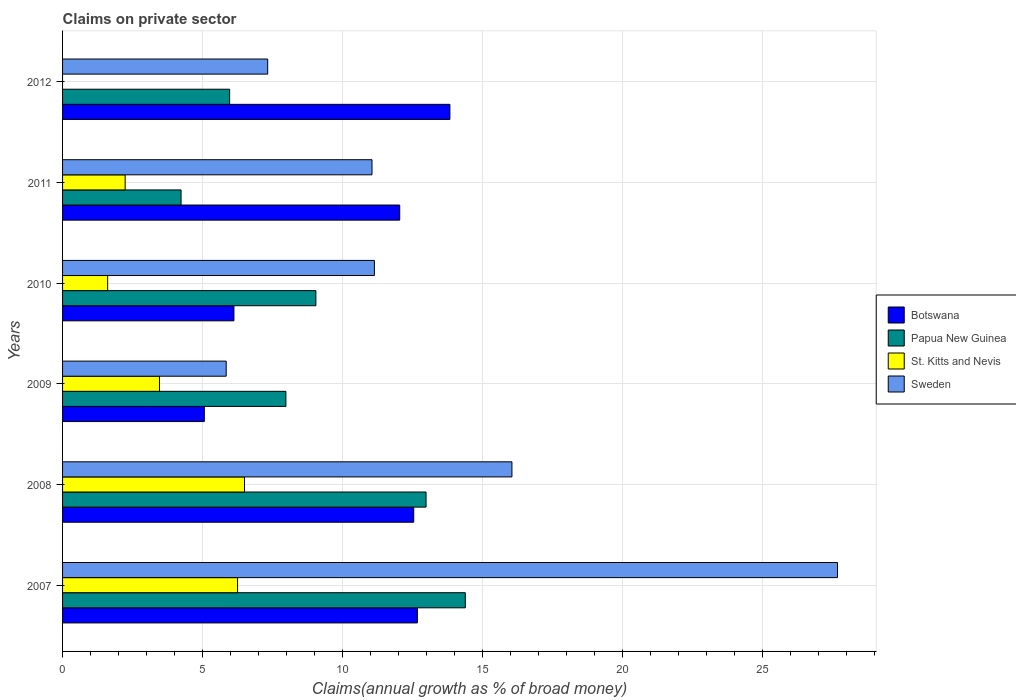How many different coloured bars are there?
Offer a very short reply. 4. Are the number of bars per tick equal to the number of legend labels?
Provide a short and direct response. No. How many bars are there on the 3rd tick from the top?
Provide a succinct answer. 4. How many bars are there on the 3rd tick from the bottom?
Make the answer very short. 4. In how many cases, is the number of bars for a given year not equal to the number of legend labels?
Your response must be concise. 1. What is the percentage of broad money claimed on private sector in Sweden in 2012?
Offer a very short reply. 7.32. Across all years, what is the maximum percentage of broad money claimed on private sector in Botswana?
Keep it short and to the point. 13.83. In which year was the percentage of broad money claimed on private sector in Botswana maximum?
Your response must be concise. 2012. What is the total percentage of broad money claimed on private sector in St. Kitts and Nevis in the graph?
Give a very brief answer. 20.05. What is the difference between the percentage of broad money claimed on private sector in Botswana in 2007 and that in 2008?
Provide a short and direct response. 0.13. What is the difference between the percentage of broad money claimed on private sector in Botswana in 2007 and the percentage of broad money claimed on private sector in St. Kitts and Nevis in 2012?
Provide a succinct answer. 12.67. What is the average percentage of broad money claimed on private sector in Botswana per year?
Offer a very short reply. 10.37. In the year 2010, what is the difference between the percentage of broad money claimed on private sector in Papua New Guinea and percentage of broad money claimed on private sector in St. Kitts and Nevis?
Offer a terse response. 7.43. In how many years, is the percentage of broad money claimed on private sector in St. Kitts and Nevis greater than 10 %?
Provide a succinct answer. 0. What is the ratio of the percentage of broad money claimed on private sector in St. Kitts and Nevis in 2007 to that in 2011?
Offer a very short reply. 2.8. Is the percentage of broad money claimed on private sector in Botswana in 2007 less than that in 2011?
Make the answer very short. No. What is the difference between the highest and the second highest percentage of broad money claimed on private sector in St. Kitts and Nevis?
Offer a very short reply. 0.25. What is the difference between the highest and the lowest percentage of broad money claimed on private sector in Papua New Guinea?
Make the answer very short. 10.15. In how many years, is the percentage of broad money claimed on private sector in Papua New Guinea greater than the average percentage of broad money claimed on private sector in Papua New Guinea taken over all years?
Ensure brevity in your answer.  2. Is the sum of the percentage of broad money claimed on private sector in Sweden in 2009 and 2010 greater than the maximum percentage of broad money claimed on private sector in St. Kitts and Nevis across all years?
Give a very brief answer. Yes. Is it the case that in every year, the sum of the percentage of broad money claimed on private sector in Papua New Guinea and percentage of broad money claimed on private sector in St. Kitts and Nevis is greater than the sum of percentage of broad money claimed on private sector in Sweden and percentage of broad money claimed on private sector in Botswana?
Provide a succinct answer. Yes. Are all the bars in the graph horizontal?
Ensure brevity in your answer.  Yes. Are the values on the major ticks of X-axis written in scientific E-notation?
Your answer should be very brief. No. Does the graph contain any zero values?
Your answer should be very brief. Yes. Does the graph contain grids?
Offer a terse response. Yes. How many legend labels are there?
Your answer should be very brief. 4. How are the legend labels stacked?
Your answer should be compact. Vertical. What is the title of the graph?
Your response must be concise. Claims on private sector. Does "Philippines" appear as one of the legend labels in the graph?
Keep it short and to the point. No. What is the label or title of the X-axis?
Provide a succinct answer. Claims(annual growth as % of broad money). What is the label or title of the Y-axis?
Make the answer very short. Years. What is the Claims(annual growth as % of broad money) in Botswana in 2007?
Offer a terse response. 12.67. What is the Claims(annual growth as % of broad money) of Papua New Guinea in 2007?
Keep it short and to the point. 14.38. What is the Claims(annual growth as % of broad money) in St. Kitts and Nevis in 2007?
Make the answer very short. 6.25. What is the Claims(annual growth as % of broad money) of Sweden in 2007?
Offer a terse response. 27.66. What is the Claims(annual growth as % of broad money) in Botswana in 2008?
Your answer should be very brief. 12.54. What is the Claims(annual growth as % of broad money) in Papua New Guinea in 2008?
Keep it short and to the point. 12.98. What is the Claims(annual growth as % of broad money) of St. Kitts and Nevis in 2008?
Provide a succinct answer. 6.5. What is the Claims(annual growth as % of broad money) in Sweden in 2008?
Your response must be concise. 16.04. What is the Claims(annual growth as % of broad money) of Botswana in 2009?
Your response must be concise. 5.06. What is the Claims(annual growth as % of broad money) of Papua New Guinea in 2009?
Ensure brevity in your answer.  7.97. What is the Claims(annual growth as % of broad money) in St. Kitts and Nevis in 2009?
Make the answer very short. 3.46. What is the Claims(annual growth as % of broad money) in Sweden in 2009?
Offer a terse response. 5.84. What is the Claims(annual growth as % of broad money) of Botswana in 2010?
Your response must be concise. 6.12. What is the Claims(annual growth as % of broad money) in Papua New Guinea in 2010?
Your answer should be very brief. 9.04. What is the Claims(annual growth as % of broad money) of St. Kitts and Nevis in 2010?
Keep it short and to the point. 1.61. What is the Claims(annual growth as % of broad money) of Sweden in 2010?
Provide a short and direct response. 11.13. What is the Claims(annual growth as % of broad money) in Botswana in 2011?
Your answer should be very brief. 12.04. What is the Claims(annual growth as % of broad money) in Papua New Guinea in 2011?
Your answer should be very brief. 4.23. What is the Claims(annual growth as % of broad money) of St. Kitts and Nevis in 2011?
Ensure brevity in your answer.  2.23. What is the Claims(annual growth as % of broad money) in Sweden in 2011?
Ensure brevity in your answer.  11.05. What is the Claims(annual growth as % of broad money) of Botswana in 2012?
Offer a very short reply. 13.83. What is the Claims(annual growth as % of broad money) in Papua New Guinea in 2012?
Give a very brief answer. 5.96. What is the Claims(annual growth as % of broad money) of Sweden in 2012?
Your answer should be compact. 7.32. Across all years, what is the maximum Claims(annual growth as % of broad money) in Botswana?
Make the answer very short. 13.83. Across all years, what is the maximum Claims(annual growth as % of broad money) of Papua New Guinea?
Keep it short and to the point. 14.38. Across all years, what is the maximum Claims(annual growth as % of broad money) in St. Kitts and Nevis?
Offer a very short reply. 6.5. Across all years, what is the maximum Claims(annual growth as % of broad money) in Sweden?
Provide a succinct answer. 27.66. Across all years, what is the minimum Claims(annual growth as % of broad money) in Botswana?
Your response must be concise. 5.06. Across all years, what is the minimum Claims(annual growth as % of broad money) in Papua New Guinea?
Your response must be concise. 4.23. Across all years, what is the minimum Claims(annual growth as % of broad money) in St. Kitts and Nevis?
Your answer should be very brief. 0. Across all years, what is the minimum Claims(annual growth as % of broad money) in Sweden?
Keep it short and to the point. 5.84. What is the total Claims(annual growth as % of broad money) in Botswana in the graph?
Make the answer very short. 62.25. What is the total Claims(annual growth as % of broad money) of Papua New Guinea in the graph?
Make the answer very short. 54.56. What is the total Claims(annual growth as % of broad money) of St. Kitts and Nevis in the graph?
Keep it short and to the point. 20.05. What is the total Claims(annual growth as % of broad money) of Sweden in the graph?
Give a very brief answer. 79.05. What is the difference between the Claims(annual growth as % of broad money) in Botswana in 2007 and that in 2008?
Your response must be concise. 0.13. What is the difference between the Claims(annual growth as % of broad money) in Papua New Guinea in 2007 and that in 2008?
Your answer should be compact. 1.4. What is the difference between the Claims(annual growth as % of broad money) in St. Kitts and Nevis in 2007 and that in 2008?
Offer a terse response. -0.25. What is the difference between the Claims(annual growth as % of broad money) of Sweden in 2007 and that in 2008?
Your answer should be compact. 11.62. What is the difference between the Claims(annual growth as % of broad money) in Botswana in 2007 and that in 2009?
Keep it short and to the point. 7.61. What is the difference between the Claims(annual growth as % of broad money) of Papua New Guinea in 2007 and that in 2009?
Your answer should be compact. 6.41. What is the difference between the Claims(annual growth as % of broad money) in St. Kitts and Nevis in 2007 and that in 2009?
Keep it short and to the point. 2.79. What is the difference between the Claims(annual growth as % of broad money) in Sweden in 2007 and that in 2009?
Your answer should be very brief. 21.82. What is the difference between the Claims(annual growth as % of broad money) of Botswana in 2007 and that in 2010?
Give a very brief answer. 6.55. What is the difference between the Claims(annual growth as % of broad money) of Papua New Guinea in 2007 and that in 2010?
Keep it short and to the point. 5.33. What is the difference between the Claims(annual growth as % of broad money) of St. Kitts and Nevis in 2007 and that in 2010?
Your answer should be very brief. 4.64. What is the difference between the Claims(annual growth as % of broad money) in Sweden in 2007 and that in 2010?
Your answer should be very brief. 16.53. What is the difference between the Claims(annual growth as % of broad money) in Botswana in 2007 and that in 2011?
Provide a short and direct response. 0.63. What is the difference between the Claims(annual growth as % of broad money) of Papua New Guinea in 2007 and that in 2011?
Your answer should be compact. 10.15. What is the difference between the Claims(annual growth as % of broad money) of St. Kitts and Nevis in 2007 and that in 2011?
Provide a succinct answer. 4.01. What is the difference between the Claims(annual growth as % of broad money) in Sweden in 2007 and that in 2011?
Provide a short and direct response. 16.62. What is the difference between the Claims(annual growth as % of broad money) of Botswana in 2007 and that in 2012?
Your answer should be compact. -1.16. What is the difference between the Claims(annual growth as % of broad money) in Papua New Guinea in 2007 and that in 2012?
Provide a succinct answer. 8.41. What is the difference between the Claims(annual growth as % of broad money) in Sweden in 2007 and that in 2012?
Your response must be concise. 20.34. What is the difference between the Claims(annual growth as % of broad money) in Botswana in 2008 and that in 2009?
Provide a succinct answer. 7.47. What is the difference between the Claims(annual growth as % of broad money) in Papua New Guinea in 2008 and that in 2009?
Offer a very short reply. 5. What is the difference between the Claims(annual growth as % of broad money) of St. Kitts and Nevis in 2008 and that in 2009?
Your answer should be very brief. 3.04. What is the difference between the Claims(annual growth as % of broad money) of Sweden in 2008 and that in 2009?
Keep it short and to the point. 10.2. What is the difference between the Claims(annual growth as % of broad money) of Botswana in 2008 and that in 2010?
Ensure brevity in your answer.  6.42. What is the difference between the Claims(annual growth as % of broad money) in Papua New Guinea in 2008 and that in 2010?
Your answer should be very brief. 3.93. What is the difference between the Claims(annual growth as % of broad money) of St. Kitts and Nevis in 2008 and that in 2010?
Keep it short and to the point. 4.89. What is the difference between the Claims(annual growth as % of broad money) in Sweden in 2008 and that in 2010?
Ensure brevity in your answer.  4.91. What is the difference between the Claims(annual growth as % of broad money) in Papua New Guinea in 2008 and that in 2011?
Provide a short and direct response. 8.75. What is the difference between the Claims(annual growth as % of broad money) in St. Kitts and Nevis in 2008 and that in 2011?
Give a very brief answer. 4.26. What is the difference between the Claims(annual growth as % of broad money) of Sweden in 2008 and that in 2011?
Provide a succinct answer. 5. What is the difference between the Claims(annual growth as % of broad money) of Botswana in 2008 and that in 2012?
Give a very brief answer. -1.29. What is the difference between the Claims(annual growth as % of broad money) of Papua New Guinea in 2008 and that in 2012?
Make the answer very short. 7.01. What is the difference between the Claims(annual growth as % of broad money) in Sweden in 2008 and that in 2012?
Your answer should be compact. 8.72. What is the difference between the Claims(annual growth as % of broad money) of Botswana in 2009 and that in 2010?
Make the answer very short. -1.06. What is the difference between the Claims(annual growth as % of broad money) of Papua New Guinea in 2009 and that in 2010?
Offer a terse response. -1.07. What is the difference between the Claims(annual growth as % of broad money) in St. Kitts and Nevis in 2009 and that in 2010?
Your answer should be compact. 1.85. What is the difference between the Claims(annual growth as % of broad money) in Sweden in 2009 and that in 2010?
Keep it short and to the point. -5.29. What is the difference between the Claims(annual growth as % of broad money) in Botswana in 2009 and that in 2011?
Your answer should be compact. -6.97. What is the difference between the Claims(annual growth as % of broad money) of Papua New Guinea in 2009 and that in 2011?
Make the answer very short. 3.74. What is the difference between the Claims(annual growth as % of broad money) of St. Kitts and Nevis in 2009 and that in 2011?
Give a very brief answer. 1.23. What is the difference between the Claims(annual growth as % of broad money) of Sweden in 2009 and that in 2011?
Provide a short and direct response. -5.2. What is the difference between the Claims(annual growth as % of broad money) in Botswana in 2009 and that in 2012?
Offer a terse response. -8.77. What is the difference between the Claims(annual growth as % of broad money) of Papua New Guinea in 2009 and that in 2012?
Your response must be concise. 2.01. What is the difference between the Claims(annual growth as % of broad money) in Sweden in 2009 and that in 2012?
Keep it short and to the point. -1.48. What is the difference between the Claims(annual growth as % of broad money) of Botswana in 2010 and that in 2011?
Your answer should be compact. -5.92. What is the difference between the Claims(annual growth as % of broad money) in Papua New Guinea in 2010 and that in 2011?
Give a very brief answer. 4.81. What is the difference between the Claims(annual growth as % of broad money) in St. Kitts and Nevis in 2010 and that in 2011?
Offer a terse response. -0.62. What is the difference between the Claims(annual growth as % of broad money) in Sweden in 2010 and that in 2011?
Provide a succinct answer. 0.09. What is the difference between the Claims(annual growth as % of broad money) in Botswana in 2010 and that in 2012?
Your response must be concise. -7.71. What is the difference between the Claims(annual growth as % of broad money) of Papua New Guinea in 2010 and that in 2012?
Make the answer very short. 3.08. What is the difference between the Claims(annual growth as % of broad money) of Sweden in 2010 and that in 2012?
Provide a short and direct response. 3.81. What is the difference between the Claims(annual growth as % of broad money) in Botswana in 2011 and that in 2012?
Your response must be concise. -1.79. What is the difference between the Claims(annual growth as % of broad money) of Papua New Guinea in 2011 and that in 2012?
Give a very brief answer. -1.73. What is the difference between the Claims(annual growth as % of broad money) of Sweden in 2011 and that in 2012?
Your answer should be very brief. 3.72. What is the difference between the Claims(annual growth as % of broad money) in Botswana in 2007 and the Claims(annual growth as % of broad money) in Papua New Guinea in 2008?
Ensure brevity in your answer.  -0.31. What is the difference between the Claims(annual growth as % of broad money) of Botswana in 2007 and the Claims(annual growth as % of broad money) of St. Kitts and Nevis in 2008?
Your answer should be very brief. 6.17. What is the difference between the Claims(annual growth as % of broad money) in Botswana in 2007 and the Claims(annual growth as % of broad money) in Sweden in 2008?
Make the answer very short. -3.38. What is the difference between the Claims(annual growth as % of broad money) of Papua New Guinea in 2007 and the Claims(annual growth as % of broad money) of St. Kitts and Nevis in 2008?
Keep it short and to the point. 7.88. What is the difference between the Claims(annual growth as % of broad money) in Papua New Guinea in 2007 and the Claims(annual growth as % of broad money) in Sweden in 2008?
Offer a terse response. -1.66. What is the difference between the Claims(annual growth as % of broad money) of St. Kitts and Nevis in 2007 and the Claims(annual growth as % of broad money) of Sweden in 2008?
Provide a succinct answer. -9.79. What is the difference between the Claims(annual growth as % of broad money) of Botswana in 2007 and the Claims(annual growth as % of broad money) of Papua New Guinea in 2009?
Give a very brief answer. 4.69. What is the difference between the Claims(annual growth as % of broad money) in Botswana in 2007 and the Claims(annual growth as % of broad money) in St. Kitts and Nevis in 2009?
Give a very brief answer. 9.21. What is the difference between the Claims(annual growth as % of broad money) of Botswana in 2007 and the Claims(annual growth as % of broad money) of Sweden in 2009?
Give a very brief answer. 6.83. What is the difference between the Claims(annual growth as % of broad money) of Papua New Guinea in 2007 and the Claims(annual growth as % of broad money) of St. Kitts and Nevis in 2009?
Your answer should be compact. 10.92. What is the difference between the Claims(annual growth as % of broad money) of Papua New Guinea in 2007 and the Claims(annual growth as % of broad money) of Sweden in 2009?
Offer a very short reply. 8.54. What is the difference between the Claims(annual growth as % of broad money) in St. Kitts and Nevis in 2007 and the Claims(annual growth as % of broad money) in Sweden in 2009?
Your answer should be compact. 0.41. What is the difference between the Claims(annual growth as % of broad money) of Botswana in 2007 and the Claims(annual growth as % of broad money) of Papua New Guinea in 2010?
Your answer should be compact. 3.62. What is the difference between the Claims(annual growth as % of broad money) in Botswana in 2007 and the Claims(annual growth as % of broad money) in St. Kitts and Nevis in 2010?
Keep it short and to the point. 11.06. What is the difference between the Claims(annual growth as % of broad money) in Botswana in 2007 and the Claims(annual growth as % of broad money) in Sweden in 2010?
Ensure brevity in your answer.  1.53. What is the difference between the Claims(annual growth as % of broad money) in Papua New Guinea in 2007 and the Claims(annual growth as % of broad money) in St. Kitts and Nevis in 2010?
Make the answer very short. 12.77. What is the difference between the Claims(annual growth as % of broad money) of Papua New Guinea in 2007 and the Claims(annual growth as % of broad money) of Sweden in 2010?
Offer a terse response. 3.25. What is the difference between the Claims(annual growth as % of broad money) of St. Kitts and Nevis in 2007 and the Claims(annual growth as % of broad money) of Sweden in 2010?
Make the answer very short. -4.88. What is the difference between the Claims(annual growth as % of broad money) of Botswana in 2007 and the Claims(annual growth as % of broad money) of Papua New Guinea in 2011?
Offer a very short reply. 8.44. What is the difference between the Claims(annual growth as % of broad money) of Botswana in 2007 and the Claims(annual growth as % of broad money) of St. Kitts and Nevis in 2011?
Provide a succinct answer. 10.43. What is the difference between the Claims(annual growth as % of broad money) of Botswana in 2007 and the Claims(annual growth as % of broad money) of Sweden in 2011?
Make the answer very short. 1.62. What is the difference between the Claims(annual growth as % of broad money) of Papua New Guinea in 2007 and the Claims(annual growth as % of broad money) of St. Kitts and Nevis in 2011?
Offer a terse response. 12.14. What is the difference between the Claims(annual growth as % of broad money) of Papua New Guinea in 2007 and the Claims(annual growth as % of broad money) of Sweden in 2011?
Keep it short and to the point. 3.33. What is the difference between the Claims(annual growth as % of broad money) in St. Kitts and Nevis in 2007 and the Claims(annual growth as % of broad money) in Sweden in 2011?
Offer a very short reply. -4.8. What is the difference between the Claims(annual growth as % of broad money) in Botswana in 2007 and the Claims(annual growth as % of broad money) in Papua New Guinea in 2012?
Your answer should be compact. 6.7. What is the difference between the Claims(annual growth as % of broad money) of Botswana in 2007 and the Claims(annual growth as % of broad money) of Sweden in 2012?
Your answer should be compact. 5.34. What is the difference between the Claims(annual growth as % of broad money) of Papua New Guinea in 2007 and the Claims(annual growth as % of broad money) of Sweden in 2012?
Ensure brevity in your answer.  7.06. What is the difference between the Claims(annual growth as % of broad money) of St. Kitts and Nevis in 2007 and the Claims(annual growth as % of broad money) of Sweden in 2012?
Keep it short and to the point. -1.08. What is the difference between the Claims(annual growth as % of broad money) of Botswana in 2008 and the Claims(annual growth as % of broad money) of Papua New Guinea in 2009?
Keep it short and to the point. 4.56. What is the difference between the Claims(annual growth as % of broad money) of Botswana in 2008 and the Claims(annual growth as % of broad money) of St. Kitts and Nevis in 2009?
Offer a terse response. 9.08. What is the difference between the Claims(annual growth as % of broad money) in Botswana in 2008 and the Claims(annual growth as % of broad money) in Sweden in 2009?
Keep it short and to the point. 6.69. What is the difference between the Claims(annual growth as % of broad money) in Papua New Guinea in 2008 and the Claims(annual growth as % of broad money) in St. Kitts and Nevis in 2009?
Your answer should be compact. 9.52. What is the difference between the Claims(annual growth as % of broad money) of Papua New Guinea in 2008 and the Claims(annual growth as % of broad money) of Sweden in 2009?
Your response must be concise. 7.13. What is the difference between the Claims(annual growth as % of broad money) of St. Kitts and Nevis in 2008 and the Claims(annual growth as % of broad money) of Sweden in 2009?
Offer a terse response. 0.65. What is the difference between the Claims(annual growth as % of broad money) in Botswana in 2008 and the Claims(annual growth as % of broad money) in Papua New Guinea in 2010?
Provide a succinct answer. 3.49. What is the difference between the Claims(annual growth as % of broad money) in Botswana in 2008 and the Claims(annual growth as % of broad money) in St. Kitts and Nevis in 2010?
Provide a short and direct response. 10.93. What is the difference between the Claims(annual growth as % of broad money) of Botswana in 2008 and the Claims(annual growth as % of broad money) of Sweden in 2010?
Your response must be concise. 1.4. What is the difference between the Claims(annual growth as % of broad money) in Papua New Guinea in 2008 and the Claims(annual growth as % of broad money) in St. Kitts and Nevis in 2010?
Offer a very short reply. 11.37. What is the difference between the Claims(annual growth as % of broad money) of Papua New Guinea in 2008 and the Claims(annual growth as % of broad money) of Sweden in 2010?
Ensure brevity in your answer.  1.84. What is the difference between the Claims(annual growth as % of broad money) of St. Kitts and Nevis in 2008 and the Claims(annual growth as % of broad money) of Sweden in 2010?
Your answer should be compact. -4.64. What is the difference between the Claims(annual growth as % of broad money) in Botswana in 2008 and the Claims(annual growth as % of broad money) in Papua New Guinea in 2011?
Provide a succinct answer. 8.31. What is the difference between the Claims(annual growth as % of broad money) of Botswana in 2008 and the Claims(annual growth as % of broad money) of St. Kitts and Nevis in 2011?
Your response must be concise. 10.3. What is the difference between the Claims(annual growth as % of broad money) of Botswana in 2008 and the Claims(annual growth as % of broad money) of Sweden in 2011?
Give a very brief answer. 1.49. What is the difference between the Claims(annual growth as % of broad money) in Papua New Guinea in 2008 and the Claims(annual growth as % of broad money) in St. Kitts and Nevis in 2011?
Ensure brevity in your answer.  10.74. What is the difference between the Claims(annual growth as % of broad money) in Papua New Guinea in 2008 and the Claims(annual growth as % of broad money) in Sweden in 2011?
Provide a succinct answer. 1.93. What is the difference between the Claims(annual growth as % of broad money) of St. Kitts and Nevis in 2008 and the Claims(annual growth as % of broad money) of Sweden in 2011?
Ensure brevity in your answer.  -4.55. What is the difference between the Claims(annual growth as % of broad money) in Botswana in 2008 and the Claims(annual growth as % of broad money) in Papua New Guinea in 2012?
Give a very brief answer. 6.57. What is the difference between the Claims(annual growth as % of broad money) of Botswana in 2008 and the Claims(annual growth as % of broad money) of Sweden in 2012?
Your answer should be compact. 5.21. What is the difference between the Claims(annual growth as % of broad money) in Papua New Guinea in 2008 and the Claims(annual growth as % of broad money) in Sweden in 2012?
Make the answer very short. 5.65. What is the difference between the Claims(annual growth as % of broad money) of St. Kitts and Nevis in 2008 and the Claims(annual growth as % of broad money) of Sweden in 2012?
Keep it short and to the point. -0.83. What is the difference between the Claims(annual growth as % of broad money) in Botswana in 2009 and the Claims(annual growth as % of broad money) in Papua New Guinea in 2010?
Offer a terse response. -3.98. What is the difference between the Claims(annual growth as % of broad money) in Botswana in 2009 and the Claims(annual growth as % of broad money) in St. Kitts and Nevis in 2010?
Ensure brevity in your answer.  3.45. What is the difference between the Claims(annual growth as % of broad money) in Botswana in 2009 and the Claims(annual growth as % of broad money) in Sweden in 2010?
Make the answer very short. -6.07. What is the difference between the Claims(annual growth as % of broad money) of Papua New Guinea in 2009 and the Claims(annual growth as % of broad money) of St. Kitts and Nevis in 2010?
Your response must be concise. 6.36. What is the difference between the Claims(annual growth as % of broad money) in Papua New Guinea in 2009 and the Claims(annual growth as % of broad money) in Sweden in 2010?
Ensure brevity in your answer.  -3.16. What is the difference between the Claims(annual growth as % of broad money) of St. Kitts and Nevis in 2009 and the Claims(annual growth as % of broad money) of Sweden in 2010?
Keep it short and to the point. -7.67. What is the difference between the Claims(annual growth as % of broad money) in Botswana in 2009 and the Claims(annual growth as % of broad money) in Papua New Guinea in 2011?
Provide a succinct answer. 0.83. What is the difference between the Claims(annual growth as % of broad money) of Botswana in 2009 and the Claims(annual growth as % of broad money) of St. Kitts and Nevis in 2011?
Provide a succinct answer. 2.83. What is the difference between the Claims(annual growth as % of broad money) of Botswana in 2009 and the Claims(annual growth as % of broad money) of Sweden in 2011?
Give a very brief answer. -5.99. What is the difference between the Claims(annual growth as % of broad money) in Papua New Guinea in 2009 and the Claims(annual growth as % of broad money) in St. Kitts and Nevis in 2011?
Ensure brevity in your answer.  5.74. What is the difference between the Claims(annual growth as % of broad money) in Papua New Guinea in 2009 and the Claims(annual growth as % of broad money) in Sweden in 2011?
Provide a short and direct response. -3.07. What is the difference between the Claims(annual growth as % of broad money) of St. Kitts and Nevis in 2009 and the Claims(annual growth as % of broad money) of Sweden in 2011?
Your response must be concise. -7.59. What is the difference between the Claims(annual growth as % of broad money) in Botswana in 2009 and the Claims(annual growth as % of broad money) in Papua New Guinea in 2012?
Give a very brief answer. -0.9. What is the difference between the Claims(annual growth as % of broad money) in Botswana in 2009 and the Claims(annual growth as % of broad money) in Sweden in 2012?
Offer a terse response. -2.26. What is the difference between the Claims(annual growth as % of broad money) in Papua New Guinea in 2009 and the Claims(annual growth as % of broad money) in Sweden in 2012?
Make the answer very short. 0.65. What is the difference between the Claims(annual growth as % of broad money) of St. Kitts and Nevis in 2009 and the Claims(annual growth as % of broad money) of Sweden in 2012?
Ensure brevity in your answer.  -3.86. What is the difference between the Claims(annual growth as % of broad money) of Botswana in 2010 and the Claims(annual growth as % of broad money) of Papua New Guinea in 2011?
Your answer should be compact. 1.89. What is the difference between the Claims(annual growth as % of broad money) of Botswana in 2010 and the Claims(annual growth as % of broad money) of St. Kitts and Nevis in 2011?
Ensure brevity in your answer.  3.88. What is the difference between the Claims(annual growth as % of broad money) in Botswana in 2010 and the Claims(annual growth as % of broad money) in Sweden in 2011?
Make the answer very short. -4.93. What is the difference between the Claims(annual growth as % of broad money) in Papua New Guinea in 2010 and the Claims(annual growth as % of broad money) in St. Kitts and Nevis in 2011?
Make the answer very short. 6.81. What is the difference between the Claims(annual growth as % of broad money) of Papua New Guinea in 2010 and the Claims(annual growth as % of broad money) of Sweden in 2011?
Provide a short and direct response. -2. What is the difference between the Claims(annual growth as % of broad money) of St. Kitts and Nevis in 2010 and the Claims(annual growth as % of broad money) of Sweden in 2011?
Your answer should be very brief. -9.44. What is the difference between the Claims(annual growth as % of broad money) in Botswana in 2010 and the Claims(annual growth as % of broad money) in Papua New Guinea in 2012?
Offer a very short reply. 0.15. What is the difference between the Claims(annual growth as % of broad money) of Botswana in 2010 and the Claims(annual growth as % of broad money) of Sweden in 2012?
Your response must be concise. -1.2. What is the difference between the Claims(annual growth as % of broad money) of Papua New Guinea in 2010 and the Claims(annual growth as % of broad money) of Sweden in 2012?
Your answer should be compact. 1.72. What is the difference between the Claims(annual growth as % of broad money) in St. Kitts and Nevis in 2010 and the Claims(annual growth as % of broad money) in Sweden in 2012?
Keep it short and to the point. -5.71. What is the difference between the Claims(annual growth as % of broad money) of Botswana in 2011 and the Claims(annual growth as % of broad money) of Papua New Guinea in 2012?
Ensure brevity in your answer.  6.07. What is the difference between the Claims(annual growth as % of broad money) in Botswana in 2011 and the Claims(annual growth as % of broad money) in Sweden in 2012?
Provide a succinct answer. 4.71. What is the difference between the Claims(annual growth as % of broad money) of Papua New Guinea in 2011 and the Claims(annual growth as % of broad money) of Sweden in 2012?
Your answer should be compact. -3.09. What is the difference between the Claims(annual growth as % of broad money) of St. Kitts and Nevis in 2011 and the Claims(annual growth as % of broad money) of Sweden in 2012?
Offer a very short reply. -5.09. What is the average Claims(annual growth as % of broad money) in Botswana per year?
Your answer should be compact. 10.37. What is the average Claims(annual growth as % of broad money) of Papua New Guinea per year?
Give a very brief answer. 9.09. What is the average Claims(annual growth as % of broad money) in St. Kitts and Nevis per year?
Keep it short and to the point. 3.34. What is the average Claims(annual growth as % of broad money) of Sweden per year?
Offer a terse response. 13.17. In the year 2007, what is the difference between the Claims(annual growth as % of broad money) in Botswana and Claims(annual growth as % of broad money) in Papua New Guinea?
Offer a terse response. -1.71. In the year 2007, what is the difference between the Claims(annual growth as % of broad money) of Botswana and Claims(annual growth as % of broad money) of St. Kitts and Nevis?
Ensure brevity in your answer.  6.42. In the year 2007, what is the difference between the Claims(annual growth as % of broad money) in Botswana and Claims(annual growth as % of broad money) in Sweden?
Make the answer very short. -15. In the year 2007, what is the difference between the Claims(annual growth as % of broad money) in Papua New Guinea and Claims(annual growth as % of broad money) in St. Kitts and Nevis?
Provide a short and direct response. 8.13. In the year 2007, what is the difference between the Claims(annual growth as % of broad money) of Papua New Guinea and Claims(annual growth as % of broad money) of Sweden?
Give a very brief answer. -13.29. In the year 2007, what is the difference between the Claims(annual growth as % of broad money) of St. Kitts and Nevis and Claims(annual growth as % of broad money) of Sweden?
Provide a short and direct response. -21.42. In the year 2008, what is the difference between the Claims(annual growth as % of broad money) in Botswana and Claims(annual growth as % of broad money) in Papua New Guinea?
Offer a very short reply. -0.44. In the year 2008, what is the difference between the Claims(annual growth as % of broad money) in Botswana and Claims(annual growth as % of broad money) in St. Kitts and Nevis?
Provide a succinct answer. 6.04. In the year 2008, what is the difference between the Claims(annual growth as % of broad money) of Botswana and Claims(annual growth as % of broad money) of Sweden?
Offer a very short reply. -3.51. In the year 2008, what is the difference between the Claims(annual growth as % of broad money) in Papua New Guinea and Claims(annual growth as % of broad money) in St. Kitts and Nevis?
Your response must be concise. 6.48. In the year 2008, what is the difference between the Claims(annual growth as % of broad money) of Papua New Guinea and Claims(annual growth as % of broad money) of Sweden?
Provide a short and direct response. -3.07. In the year 2008, what is the difference between the Claims(annual growth as % of broad money) in St. Kitts and Nevis and Claims(annual growth as % of broad money) in Sweden?
Offer a very short reply. -9.55. In the year 2009, what is the difference between the Claims(annual growth as % of broad money) of Botswana and Claims(annual growth as % of broad money) of Papua New Guinea?
Provide a short and direct response. -2.91. In the year 2009, what is the difference between the Claims(annual growth as % of broad money) in Botswana and Claims(annual growth as % of broad money) in St. Kitts and Nevis?
Your answer should be compact. 1.6. In the year 2009, what is the difference between the Claims(annual growth as % of broad money) of Botswana and Claims(annual growth as % of broad money) of Sweden?
Keep it short and to the point. -0.78. In the year 2009, what is the difference between the Claims(annual growth as % of broad money) of Papua New Guinea and Claims(annual growth as % of broad money) of St. Kitts and Nevis?
Ensure brevity in your answer.  4.51. In the year 2009, what is the difference between the Claims(annual growth as % of broad money) in Papua New Guinea and Claims(annual growth as % of broad money) in Sweden?
Give a very brief answer. 2.13. In the year 2009, what is the difference between the Claims(annual growth as % of broad money) of St. Kitts and Nevis and Claims(annual growth as % of broad money) of Sweden?
Give a very brief answer. -2.38. In the year 2010, what is the difference between the Claims(annual growth as % of broad money) of Botswana and Claims(annual growth as % of broad money) of Papua New Guinea?
Offer a terse response. -2.93. In the year 2010, what is the difference between the Claims(annual growth as % of broad money) of Botswana and Claims(annual growth as % of broad money) of St. Kitts and Nevis?
Give a very brief answer. 4.51. In the year 2010, what is the difference between the Claims(annual growth as % of broad money) of Botswana and Claims(annual growth as % of broad money) of Sweden?
Provide a succinct answer. -5.01. In the year 2010, what is the difference between the Claims(annual growth as % of broad money) in Papua New Guinea and Claims(annual growth as % of broad money) in St. Kitts and Nevis?
Keep it short and to the point. 7.43. In the year 2010, what is the difference between the Claims(annual growth as % of broad money) in Papua New Guinea and Claims(annual growth as % of broad money) in Sweden?
Your answer should be very brief. -2.09. In the year 2010, what is the difference between the Claims(annual growth as % of broad money) in St. Kitts and Nevis and Claims(annual growth as % of broad money) in Sweden?
Provide a succinct answer. -9.52. In the year 2011, what is the difference between the Claims(annual growth as % of broad money) in Botswana and Claims(annual growth as % of broad money) in Papua New Guinea?
Give a very brief answer. 7.81. In the year 2011, what is the difference between the Claims(annual growth as % of broad money) in Botswana and Claims(annual growth as % of broad money) in St. Kitts and Nevis?
Your answer should be compact. 9.8. In the year 2011, what is the difference between the Claims(annual growth as % of broad money) in Botswana and Claims(annual growth as % of broad money) in Sweden?
Make the answer very short. 0.99. In the year 2011, what is the difference between the Claims(annual growth as % of broad money) of Papua New Guinea and Claims(annual growth as % of broad money) of St. Kitts and Nevis?
Ensure brevity in your answer.  2. In the year 2011, what is the difference between the Claims(annual growth as % of broad money) of Papua New Guinea and Claims(annual growth as % of broad money) of Sweden?
Keep it short and to the point. -6.82. In the year 2011, what is the difference between the Claims(annual growth as % of broad money) in St. Kitts and Nevis and Claims(annual growth as % of broad money) in Sweden?
Provide a succinct answer. -8.81. In the year 2012, what is the difference between the Claims(annual growth as % of broad money) in Botswana and Claims(annual growth as % of broad money) in Papua New Guinea?
Your answer should be very brief. 7.86. In the year 2012, what is the difference between the Claims(annual growth as % of broad money) of Botswana and Claims(annual growth as % of broad money) of Sweden?
Give a very brief answer. 6.5. In the year 2012, what is the difference between the Claims(annual growth as % of broad money) in Papua New Guinea and Claims(annual growth as % of broad money) in Sweden?
Provide a succinct answer. -1.36. What is the ratio of the Claims(annual growth as % of broad money) in Botswana in 2007 to that in 2008?
Offer a terse response. 1.01. What is the ratio of the Claims(annual growth as % of broad money) of Papua New Guinea in 2007 to that in 2008?
Make the answer very short. 1.11. What is the ratio of the Claims(annual growth as % of broad money) of St. Kitts and Nevis in 2007 to that in 2008?
Provide a short and direct response. 0.96. What is the ratio of the Claims(annual growth as % of broad money) in Sweden in 2007 to that in 2008?
Ensure brevity in your answer.  1.72. What is the ratio of the Claims(annual growth as % of broad money) in Botswana in 2007 to that in 2009?
Ensure brevity in your answer.  2.5. What is the ratio of the Claims(annual growth as % of broad money) of Papua New Guinea in 2007 to that in 2009?
Provide a succinct answer. 1.8. What is the ratio of the Claims(annual growth as % of broad money) of St. Kitts and Nevis in 2007 to that in 2009?
Your answer should be very brief. 1.81. What is the ratio of the Claims(annual growth as % of broad money) of Sweden in 2007 to that in 2009?
Your answer should be very brief. 4.74. What is the ratio of the Claims(annual growth as % of broad money) in Botswana in 2007 to that in 2010?
Make the answer very short. 2.07. What is the ratio of the Claims(annual growth as % of broad money) in Papua New Guinea in 2007 to that in 2010?
Keep it short and to the point. 1.59. What is the ratio of the Claims(annual growth as % of broad money) in St. Kitts and Nevis in 2007 to that in 2010?
Give a very brief answer. 3.88. What is the ratio of the Claims(annual growth as % of broad money) of Sweden in 2007 to that in 2010?
Provide a short and direct response. 2.49. What is the ratio of the Claims(annual growth as % of broad money) in Botswana in 2007 to that in 2011?
Provide a succinct answer. 1.05. What is the ratio of the Claims(annual growth as % of broad money) of Papua New Guinea in 2007 to that in 2011?
Make the answer very short. 3.4. What is the ratio of the Claims(annual growth as % of broad money) in St. Kitts and Nevis in 2007 to that in 2011?
Ensure brevity in your answer.  2.8. What is the ratio of the Claims(annual growth as % of broad money) in Sweden in 2007 to that in 2011?
Your answer should be very brief. 2.5. What is the ratio of the Claims(annual growth as % of broad money) in Botswana in 2007 to that in 2012?
Your answer should be very brief. 0.92. What is the ratio of the Claims(annual growth as % of broad money) of Papua New Guinea in 2007 to that in 2012?
Provide a succinct answer. 2.41. What is the ratio of the Claims(annual growth as % of broad money) in Sweden in 2007 to that in 2012?
Make the answer very short. 3.78. What is the ratio of the Claims(annual growth as % of broad money) in Botswana in 2008 to that in 2009?
Your answer should be very brief. 2.48. What is the ratio of the Claims(annual growth as % of broad money) of Papua New Guinea in 2008 to that in 2009?
Give a very brief answer. 1.63. What is the ratio of the Claims(annual growth as % of broad money) of St. Kitts and Nevis in 2008 to that in 2009?
Make the answer very short. 1.88. What is the ratio of the Claims(annual growth as % of broad money) of Sweden in 2008 to that in 2009?
Offer a terse response. 2.75. What is the ratio of the Claims(annual growth as % of broad money) in Botswana in 2008 to that in 2010?
Ensure brevity in your answer.  2.05. What is the ratio of the Claims(annual growth as % of broad money) in Papua New Guinea in 2008 to that in 2010?
Offer a terse response. 1.43. What is the ratio of the Claims(annual growth as % of broad money) of St. Kitts and Nevis in 2008 to that in 2010?
Keep it short and to the point. 4.04. What is the ratio of the Claims(annual growth as % of broad money) of Sweden in 2008 to that in 2010?
Make the answer very short. 1.44. What is the ratio of the Claims(annual growth as % of broad money) in Botswana in 2008 to that in 2011?
Provide a succinct answer. 1.04. What is the ratio of the Claims(annual growth as % of broad money) in Papua New Guinea in 2008 to that in 2011?
Keep it short and to the point. 3.07. What is the ratio of the Claims(annual growth as % of broad money) of St. Kitts and Nevis in 2008 to that in 2011?
Your response must be concise. 2.91. What is the ratio of the Claims(annual growth as % of broad money) of Sweden in 2008 to that in 2011?
Ensure brevity in your answer.  1.45. What is the ratio of the Claims(annual growth as % of broad money) in Botswana in 2008 to that in 2012?
Make the answer very short. 0.91. What is the ratio of the Claims(annual growth as % of broad money) in Papua New Guinea in 2008 to that in 2012?
Give a very brief answer. 2.18. What is the ratio of the Claims(annual growth as % of broad money) in Sweden in 2008 to that in 2012?
Provide a succinct answer. 2.19. What is the ratio of the Claims(annual growth as % of broad money) of Botswana in 2009 to that in 2010?
Your response must be concise. 0.83. What is the ratio of the Claims(annual growth as % of broad money) of Papua New Guinea in 2009 to that in 2010?
Ensure brevity in your answer.  0.88. What is the ratio of the Claims(annual growth as % of broad money) in St. Kitts and Nevis in 2009 to that in 2010?
Your answer should be very brief. 2.15. What is the ratio of the Claims(annual growth as % of broad money) in Sweden in 2009 to that in 2010?
Offer a very short reply. 0.52. What is the ratio of the Claims(annual growth as % of broad money) of Botswana in 2009 to that in 2011?
Your response must be concise. 0.42. What is the ratio of the Claims(annual growth as % of broad money) of Papua New Guinea in 2009 to that in 2011?
Your answer should be very brief. 1.88. What is the ratio of the Claims(annual growth as % of broad money) of St. Kitts and Nevis in 2009 to that in 2011?
Provide a succinct answer. 1.55. What is the ratio of the Claims(annual growth as % of broad money) of Sweden in 2009 to that in 2011?
Provide a short and direct response. 0.53. What is the ratio of the Claims(annual growth as % of broad money) of Botswana in 2009 to that in 2012?
Your answer should be very brief. 0.37. What is the ratio of the Claims(annual growth as % of broad money) in Papua New Guinea in 2009 to that in 2012?
Keep it short and to the point. 1.34. What is the ratio of the Claims(annual growth as % of broad money) in Sweden in 2009 to that in 2012?
Keep it short and to the point. 0.8. What is the ratio of the Claims(annual growth as % of broad money) of Botswana in 2010 to that in 2011?
Ensure brevity in your answer.  0.51. What is the ratio of the Claims(annual growth as % of broad money) of Papua New Guinea in 2010 to that in 2011?
Offer a terse response. 2.14. What is the ratio of the Claims(annual growth as % of broad money) in St. Kitts and Nevis in 2010 to that in 2011?
Ensure brevity in your answer.  0.72. What is the ratio of the Claims(annual growth as % of broad money) of Sweden in 2010 to that in 2011?
Keep it short and to the point. 1.01. What is the ratio of the Claims(annual growth as % of broad money) of Botswana in 2010 to that in 2012?
Provide a succinct answer. 0.44. What is the ratio of the Claims(annual growth as % of broad money) of Papua New Guinea in 2010 to that in 2012?
Your answer should be very brief. 1.52. What is the ratio of the Claims(annual growth as % of broad money) in Sweden in 2010 to that in 2012?
Give a very brief answer. 1.52. What is the ratio of the Claims(annual growth as % of broad money) of Botswana in 2011 to that in 2012?
Keep it short and to the point. 0.87. What is the ratio of the Claims(annual growth as % of broad money) of Papua New Guinea in 2011 to that in 2012?
Provide a succinct answer. 0.71. What is the ratio of the Claims(annual growth as % of broad money) in Sweden in 2011 to that in 2012?
Ensure brevity in your answer.  1.51. What is the difference between the highest and the second highest Claims(annual growth as % of broad money) of Botswana?
Provide a short and direct response. 1.16. What is the difference between the highest and the second highest Claims(annual growth as % of broad money) of Papua New Guinea?
Your answer should be compact. 1.4. What is the difference between the highest and the second highest Claims(annual growth as % of broad money) in St. Kitts and Nevis?
Your answer should be compact. 0.25. What is the difference between the highest and the second highest Claims(annual growth as % of broad money) of Sweden?
Offer a terse response. 11.62. What is the difference between the highest and the lowest Claims(annual growth as % of broad money) of Botswana?
Make the answer very short. 8.77. What is the difference between the highest and the lowest Claims(annual growth as % of broad money) in Papua New Guinea?
Offer a very short reply. 10.15. What is the difference between the highest and the lowest Claims(annual growth as % of broad money) of St. Kitts and Nevis?
Give a very brief answer. 6.5. What is the difference between the highest and the lowest Claims(annual growth as % of broad money) in Sweden?
Your response must be concise. 21.82. 